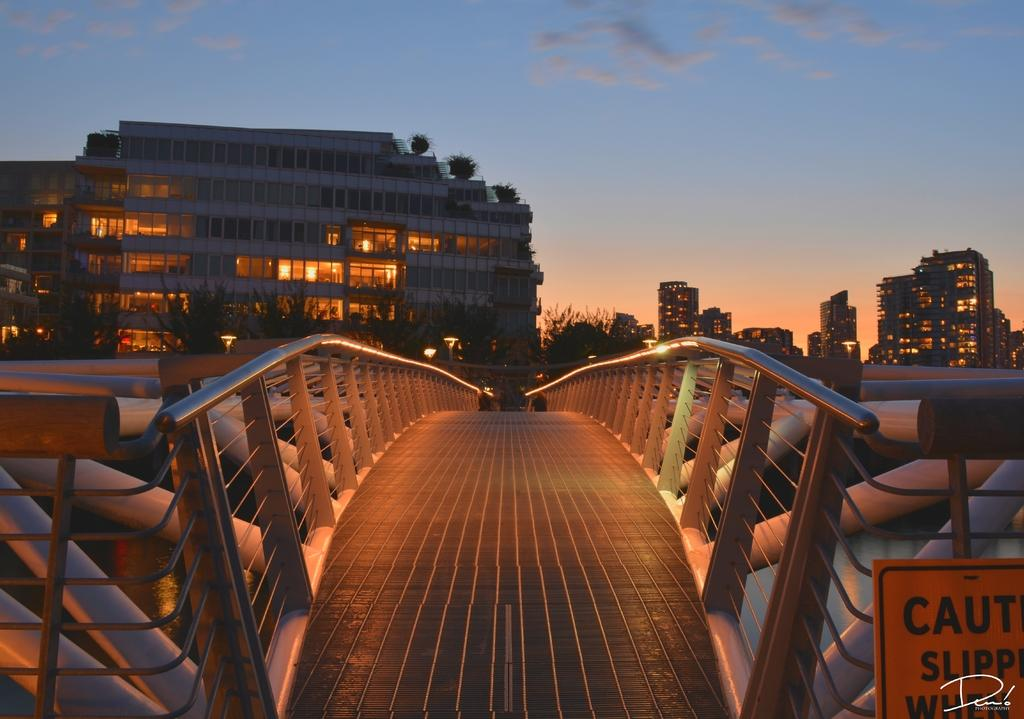<image>
Summarize the visual content of the image. a bridge with a sign in front of it that says caution and slippery 